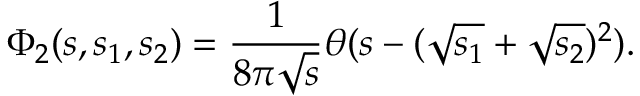Convert formula to latex. <formula><loc_0><loc_0><loc_500><loc_500>\Phi _ { 2 } ( s , s _ { 1 } , s _ { 2 } ) = \frac { 1 } 8 \pi \sqrt { s } } \theta ( s - ( \sqrt { s _ { 1 } } + \sqrt { s _ { 2 } } ) ^ { 2 } ) .</formula> 